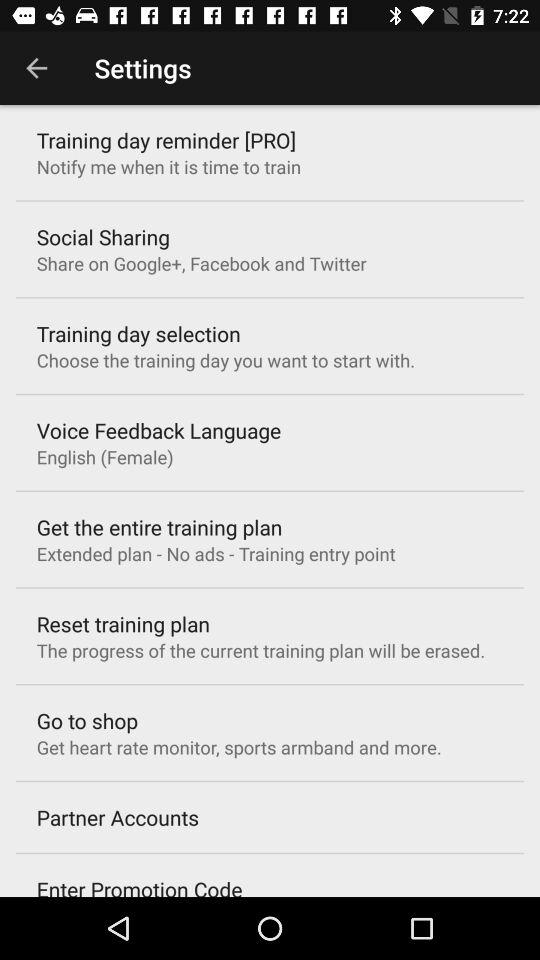What is the setting for "Go to shop"? The setting is "Get heart rate monitor, sports armband and more.". 